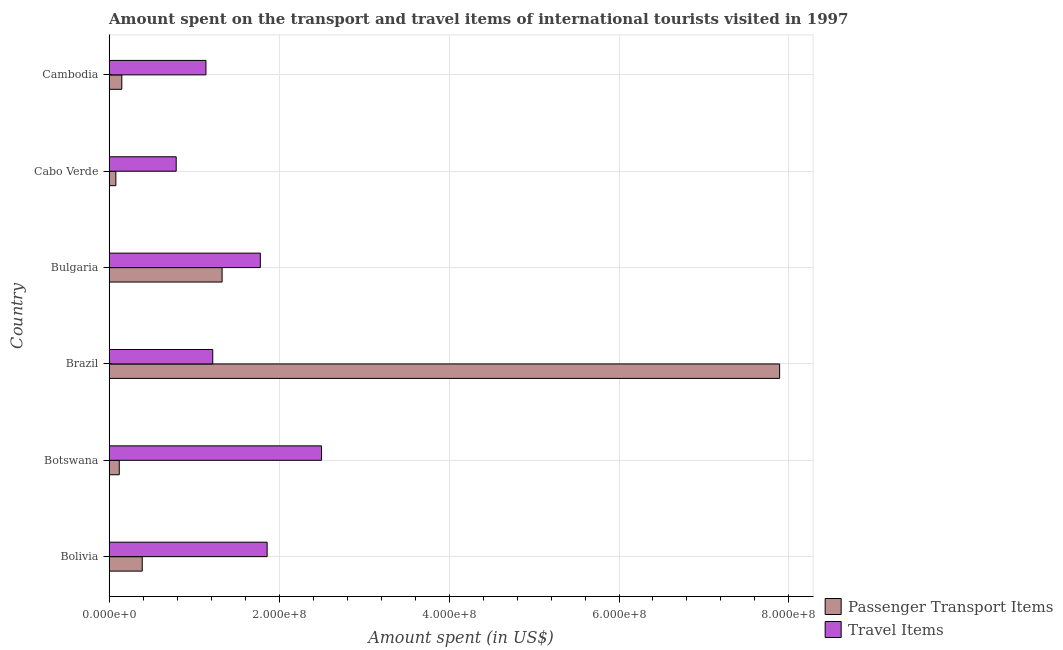Are the number of bars per tick equal to the number of legend labels?
Offer a very short reply. Yes. Are the number of bars on each tick of the Y-axis equal?
Ensure brevity in your answer.  Yes. How many bars are there on the 6th tick from the top?
Give a very brief answer. 2. How many bars are there on the 4th tick from the bottom?
Offer a terse response. 2. What is the label of the 5th group of bars from the top?
Make the answer very short. Botswana. What is the amount spent on passenger transport items in Bolivia?
Provide a succinct answer. 3.90e+07. Across all countries, what is the maximum amount spent in travel items?
Offer a terse response. 2.50e+08. In which country was the amount spent on passenger transport items maximum?
Provide a short and direct response. Brazil. In which country was the amount spent on passenger transport items minimum?
Provide a succinct answer. Cabo Verde. What is the total amount spent in travel items in the graph?
Your answer should be compact. 9.29e+08. What is the difference between the amount spent on passenger transport items in Brazil and the amount spent in travel items in Cabo Verde?
Ensure brevity in your answer.  7.10e+08. What is the average amount spent in travel items per country?
Your response must be concise. 1.55e+08. What is the difference between the amount spent in travel items and amount spent on passenger transport items in Bolivia?
Provide a short and direct response. 1.47e+08. What is the ratio of the amount spent on passenger transport items in Bolivia to that in Brazil?
Your response must be concise. 0.05. Is the difference between the amount spent in travel items in Cabo Verde and Cambodia greater than the difference between the amount spent on passenger transport items in Cabo Verde and Cambodia?
Your answer should be very brief. No. What is the difference between the highest and the second highest amount spent on passenger transport items?
Offer a terse response. 6.56e+08. What is the difference between the highest and the lowest amount spent in travel items?
Provide a short and direct response. 1.71e+08. Is the sum of the amount spent in travel items in Bolivia and Cabo Verde greater than the maximum amount spent on passenger transport items across all countries?
Ensure brevity in your answer.  No. What does the 1st bar from the top in Cabo Verde represents?
Provide a short and direct response. Travel Items. What does the 2nd bar from the bottom in Bulgaria represents?
Make the answer very short. Travel Items. How many countries are there in the graph?
Your answer should be very brief. 6. What is the difference between two consecutive major ticks on the X-axis?
Your response must be concise. 2.00e+08. Are the values on the major ticks of X-axis written in scientific E-notation?
Make the answer very short. Yes. Does the graph contain grids?
Keep it short and to the point. Yes. Where does the legend appear in the graph?
Offer a terse response. Bottom right. How many legend labels are there?
Keep it short and to the point. 2. What is the title of the graph?
Ensure brevity in your answer.  Amount spent on the transport and travel items of international tourists visited in 1997. What is the label or title of the X-axis?
Your answer should be compact. Amount spent (in US$). What is the label or title of the Y-axis?
Make the answer very short. Country. What is the Amount spent (in US$) in Passenger Transport Items in Bolivia?
Provide a short and direct response. 3.90e+07. What is the Amount spent (in US$) of Travel Items in Bolivia?
Provide a short and direct response. 1.86e+08. What is the Amount spent (in US$) in Travel Items in Botswana?
Offer a very short reply. 2.50e+08. What is the Amount spent (in US$) in Passenger Transport Items in Brazil?
Make the answer very short. 7.89e+08. What is the Amount spent (in US$) of Travel Items in Brazil?
Make the answer very short. 1.22e+08. What is the Amount spent (in US$) of Passenger Transport Items in Bulgaria?
Make the answer very short. 1.33e+08. What is the Amount spent (in US$) of Travel Items in Bulgaria?
Keep it short and to the point. 1.78e+08. What is the Amount spent (in US$) of Travel Items in Cabo Verde?
Make the answer very short. 7.90e+07. What is the Amount spent (in US$) of Passenger Transport Items in Cambodia?
Make the answer very short. 1.50e+07. What is the Amount spent (in US$) of Travel Items in Cambodia?
Your answer should be compact. 1.14e+08. Across all countries, what is the maximum Amount spent (in US$) of Passenger Transport Items?
Provide a succinct answer. 7.89e+08. Across all countries, what is the maximum Amount spent (in US$) in Travel Items?
Offer a terse response. 2.50e+08. Across all countries, what is the minimum Amount spent (in US$) in Travel Items?
Ensure brevity in your answer.  7.90e+07. What is the total Amount spent (in US$) in Passenger Transport Items in the graph?
Give a very brief answer. 9.96e+08. What is the total Amount spent (in US$) in Travel Items in the graph?
Your answer should be compact. 9.29e+08. What is the difference between the Amount spent (in US$) in Passenger Transport Items in Bolivia and that in Botswana?
Give a very brief answer. 2.70e+07. What is the difference between the Amount spent (in US$) of Travel Items in Bolivia and that in Botswana?
Offer a terse response. -6.40e+07. What is the difference between the Amount spent (in US$) of Passenger Transport Items in Bolivia and that in Brazil?
Your response must be concise. -7.50e+08. What is the difference between the Amount spent (in US$) of Travel Items in Bolivia and that in Brazil?
Offer a very short reply. 6.40e+07. What is the difference between the Amount spent (in US$) of Passenger Transport Items in Bolivia and that in Bulgaria?
Your answer should be compact. -9.40e+07. What is the difference between the Amount spent (in US$) of Travel Items in Bolivia and that in Bulgaria?
Offer a very short reply. 8.00e+06. What is the difference between the Amount spent (in US$) of Passenger Transport Items in Bolivia and that in Cabo Verde?
Make the answer very short. 3.10e+07. What is the difference between the Amount spent (in US$) in Travel Items in Bolivia and that in Cabo Verde?
Offer a very short reply. 1.07e+08. What is the difference between the Amount spent (in US$) in Passenger Transport Items in Bolivia and that in Cambodia?
Ensure brevity in your answer.  2.40e+07. What is the difference between the Amount spent (in US$) of Travel Items in Bolivia and that in Cambodia?
Offer a very short reply. 7.20e+07. What is the difference between the Amount spent (in US$) of Passenger Transport Items in Botswana and that in Brazil?
Provide a succinct answer. -7.77e+08. What is the difference between the Amount spent (in US$) in Travel Items in Botswana and that in Brazil?
Your response must be concise. 1.28e+08. What is the difference between the Amount spent (in US$) in Passenger Transport Items in Botswana and that in Bulgaria?
Your answer should be compact. -1.21e+08. What is the difference between the Amount spent (in US$) of Travel Items in Botswana and that in Bulgaria?
Your response must be concise. 7.20e+07. What is the difference between the Amount spent (in US$) of Travel Items in Botswana and that in Cabo Verde?
Your answer should be compact. 1.71e+08. What is the difference between the Amount spent (in US$) of Travel Items in Botswana and that in Cambodia?
Your response must be concise. 1.36e+08. What is the difference between the Amount spent (in US$) in Passenger Transport Items in Brazil and that in Bulgaria?
Offer a very short reply. 6.56e+08. What is the difference between the Amount spent (in US$) in Travel Items in Brazil and that in Bulgaria?
Provide a succinct answer. -5.60e+07. What is the difference between the Amount spent (in US$) in Passenger Transport Items in Brazil and that in Cabo Verde?
Your answer should be compact. 7.81e+08. What is the difference between the Amount spent (in US$) of Travel Items in Brazil and that in Cabo Verde?
Provide a short and direct response. 4.30e+07. What is the difference between the Amount spent (in US$) of Passenger Transport Items in Brazil and that in Cambodia?
Provide a short and direct response. 7.74e+08. What is the difference between the Amount spent (in US$) of Travel Items in Brazil and that in Cambodia?
Ensure brevity in your answer.  8.00e+06. What is the difference between the Amount spent (in US$) in Passenger Transport Items in Bulgaria and that in Cabo Verde?
Your response must be concise. 1.25e+08. What is the difference between the Amount spent (in US$) of Travel Items in Bulgaria and that in Cabo Verde?
Make the answer very short. 9.90e+07. What is the difference between the Amount spent (in US$) of Passenger Transport Items in Bulgaria and that in Cambodia?
Offer a very short reply. 1.18e+08. What is the difference between the Amount spent (in US$) of Travel Items in Bulgaria and that in Cambodia?
Keep it short and to the point. 6.40e+07. What is the difference between the Amount spent (in US$) of Passenger Transport Items in Cabo Verde and that in Cambodia?
Offer a terse response. -7.00e+06. What is the difference between the Amount spent (in US$) in Travel Items in Cabo Verde and that in Cambodia?
Provide a short and direct response. -3.50e+07. What is the difference between the Amount spent (in US$) of Passenger Transport Items in Bolivia and the Amount spent (in US$) of Travel Items in Botswana?
Keep it short and to the point. -2.11e+08. What is the difference between the Amount spent (in US$) in Passenger Transport Items in Bolivia and the Amount spent (in US$) in Travel Items in Brazil?
Keep it short and to the point. -8.30e+07. What is the difference between the Amount spent (in US$) of Passenger Transport Items in Bolivia and the Amount spent (in US$) of Travel Items in Bulgaria?
Provide a short and direct response. -1.39e+08. What is the difference between the Amount spent (in US$) of Passenger Transport Items in Bolivia and the Amount spent (in US$) of Travel Items in Cabo Verde?
Make the answer very short. -4.00e+07. What is the difference between the Amount spent (in US$) of Passenger Transport Items in Bolivia and the Amount spent (in US$) of Travel Items in Cambodia?
Ensure brevity in your answer.  -7.50e+07. What is the difference between the Amount spent (in US$) of Passenger Transport Items in Botswana and the Amount spent (in US$) of Travel Items in Brazil?
Offer a very short reply. -1.10e+08. What is the difference between the Amount spent (in US$) in Passenger Transport Items in Botswana and the Amount spent (in US$) in Travel Items in Bulgaria?
Give a very brief answer. -1.66e+08. What is the difference between the Amount spent (in US$) in Passenger Transport Items in Botswana and the Amount spent (in US$) in Travel Items in Cabo Verde?
Provide a succinct answer. -6.70e+07. What is the difference between the Amount spent (in US$) of Passenger Transport Items in Botswana and the Amount spent (in US$) of Travel Items in Cambodia?
Offer a very short reply. -1.02e+08. What is the difference between the Amount spent (in US$) in Passenger Transport Items in Brazil and the Amount spent (in US$) in Travel Items in Bulgaria?
Your answer should be compact. 6.11e+08. What is the difference between the Amount spent (in US$) of Passenger Transport Items in Brazil and the Amount spent (in US$) of Travel Items in Cabo Verde?
Offer a very short reply. 7.10e+08. What is the difference between the Amount spent (in US$) of Passenger Transport Items in Brazil and the Amount spent (in US$) of Travel Items in Cambodia?
Offer a very short reply. 6.75e+08. What is the difference between the Amount spent (in US$) of Passenger Transport Items in Bulgaria and the Amount spent (in US$) of Travel Items in Cabo Verde?
Your answer should be compact. 5.40e+07. What is the difference between the Amount spent (in US$) of Passenger Transport Items in Bulgaria and the Amount spent (in US$) of Travel Items in Cambodia?
Offer a very short reply. 1.90e+07. What is the difference between the Amount spent (in US$) of Passenger Transport Items in Cabo Verde and the Amount spent (in US$) of Travel Items in Cambodia?
Ensure brevity in your answer.  -1.06e+08. What is the average Amount spent (in US$) of Passenger Transport Items per country?
Make the answer very short. 1.66e+08. What is the average Amount spent (in US$) in Travel Items per country?
Your response must be concise. 1.55e+08. What is the difference between the Amount spent (in US$) in Passenger Transport Items and Amount spent (in US$) in Travel Items in Bolivia?
Ensure brevity in your answer.  -1.47e+08. What is the difference between the Amount spent (in US$) of Passenger Transport Items and Amount spent (in US$) of Travel Items in Botswana?
Provide a short and direct response. -2.38e+08. What is the difference between the Amount spent (in US$) of Passenger Transport Items and Amount spent (in US$) of Travel Items in Brazil?
Keep it short and to the point. 6.67e+08. What is the difference between the Amount spent (in US$) in Passenger Transport Items and Amount spent (in US$) in Travel Items in Bulgaria?
Provide a short and direct response. -4.50e+07. What is the difference between the Amount spent (in US$) of Passenger Transport Items and Amount spent (in US$) of Travel Items in Cabo Verde?
Your response must be concise. -7.10e+07. What is the difference between the Amount spent (in US$) of Passenger Transport Items and Amount spent (in US$) of Travel Items in Cambodia?
Keep it short and to the point. -9.90e+07. What is the ratio of the Amount spent (in US$) of Travel Items in Bolivia to that in Botswana?
Provide a succinct answer. 0.74. What is the ratio of the Amount spent (in US$) in Passenger Transport Items in Bolivia to that in Brazil?
Your answer should be compact. 0.05. What is the ratio of the Amount spent (in US$) in Travel Items in Bolivia to that in Brazil?
Your response must be concise. 1.52. What is the ratio of the Amount spent (in US$) of Passenger Transport Items in Bolivia to that in Bulgaria?
Provide a succinct answer. 0.29. What is the ratio of the Amount spent (in US$) in Travel Items in Bolivia to that in Bulgaria?
Ensure brevity in your answer.  1.04. What is the ratio of the Amount spent (in US$) of Passenger Transport Items in Bolivia to that in Cabo Verde?
Your answer should be very brief. 4.88. What is the ratio of the Amount spent (in US$) of Travel Items in Bolivia to that in Cabo Verde?
Give a very brief answer. 2.35. What is the ratio of the Amount spent (in US$) in Passenger Transport Items in Bolivia to that in Cambodia?
Your answer should be very brief. 2.6. What is the ratio of the Amount spent (in US$) in Travel Items in Bolivia to that in Cambodia?
Offer a terse response. 1.63. What is the ratio of the Amount spent (in US$) of Passenger Transport Items in Botswana to that in Brazil?
Your answer should be very brief. 0.02. What is the ratio of the Amount spent (in US$) of Travel Items in Botswana to that in Brazil?
Provide a succinct answer. 2.05. What is the ratio of the Amount spent (in US$) of Passenger Transport Items in Botswana to that in Bulgaria?
Keep it short and to the point. 0.09. What is the ratio of the Amount spent (in US$) in Travel Items in Botswana to that in Bulgaria?
Your answer should be very brief. 1.4. What is the ratio of the Amount spent (in US$) of Passenger Transport Items in Botswana to that in Cabo Verde?
Give a very brief answer. 1.5. What is the ratio of the Amount spent (in US$) of Travel Items in Botswana to that in Cabo Verde?
Provide a succinct answer. 3.16. What is the ratio of the Amount spent (in US$) of Travel Items in Botswana to that in Cambodia?
Provide a short and direct response. 2.19. What is the ratio of the Amount spent (in US$) of Passenger Transport Items in Brazil to that in Bulgaria?
Provide a succinct answer. 5.93. What is the ratio of the Amount spent (in US$) in Travel Items in Brazil to that in Bulgaria?
Make the answer very short. 0.69. What is the ratio of the Amount spent (in US$) in Passenger Transport Items in Brazil to that in Cabo Verde?
Keep it short and to the point. 98.62. What is the ratio of the Amount spent (in US$) of Travel Items in Brazil to that in Cabo Verde?
Offer a very short reply. 1.54. What is the ratio of the Amount spent (in US$) in Passenger Transport Items in Brazil to that in Cambodia?
Keep it short and to the point. 52.6. What is the ratio of the Amount spent (in US$) of Travel Items in Brazil to that in Cambodia?
Make the answer very short. 1.07. What is the ratio of the Amount spent (in US$) in Passenger Transport Items in Bulgaria to that in Cabo Verde?
Give a very brief answer. 16.62. What is the ratio of the Amount spent (in US$) in Travel Items in Bulgaria to that in Cabo Verde?
Offer a terse response. 2.25. What is the ratio of the Amount spent (in US$) in Passenger Transport Items in Bulgaria to that in Cambodia?
Give a very brief answer. 8.87. What is the ratio of the Amount spent (in US$) in Travel Items in Bulgaria to that in Cambodia?
Keep it short and to the point. 1.56. What is the ratio of the Amount spent (in US$) of Passenger Transport Items in Cabo Verde to that in Cambodia?
Give a very brief answer. 0.53. What is the ratio of the Amount spent (in US$) of Travel Items in Cabo Verde to that in Cambodia?
Provide a succinct answer. 0.69. What is the difference between the highest and the second highest Amount spent (in US$) in Passenger Transport Items?
Your response must be concise. 6.56e+08. What is the difference between the highest and the second highest Amount spent (in US$) in Travel Items?
Ensure brevity in your answer.  6.40e+07. What is the difference between the highest and the lowest Amount spent (in US$) in Passenger Transport Items?
Ensure brevity in your answer.  7.81e+08. What is the difference between the highest and the lowest Amount spent (in US$) in Travel Items?
Ensure brevity in your answer.  1.71e+08. 